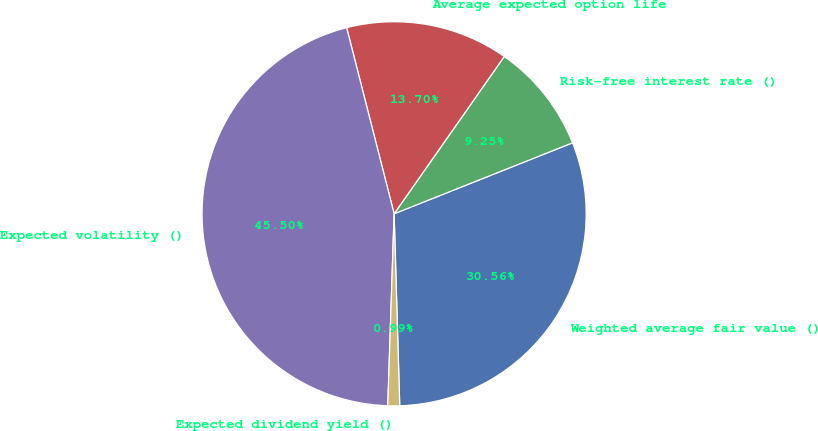Convert chart to OTSL. <chart><loc_0><loc_0><loc_500><loc_500><pie_chart><fcel>Weighted average fair value ()<fcel>Risk-free interest rate ()<fcel>Average expected option life<fcel>Expected volatility ()<fcel>Expected dividend yield ()<nl><fcel>30.56%<fcel>9.25%<fcel>13.7%<fcel>45.5%<fcel>0.99%<nl></chart> 